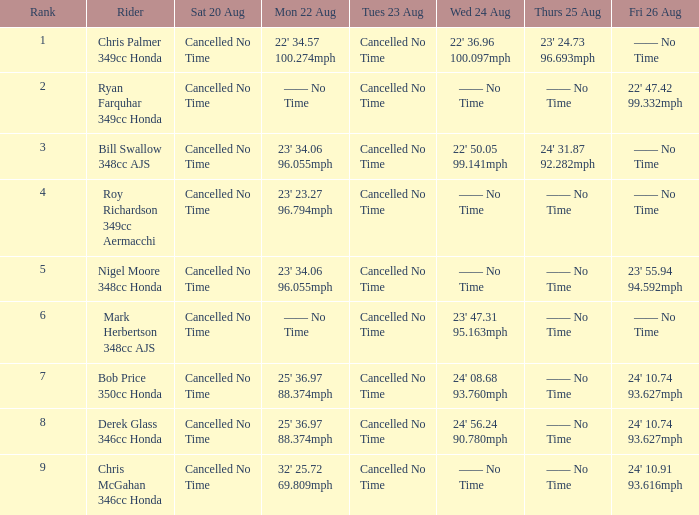What is every entry for Tuesday August 23 when Thursday August 25 is 24' 31.87 92.282mph? Cancelled No Time. 